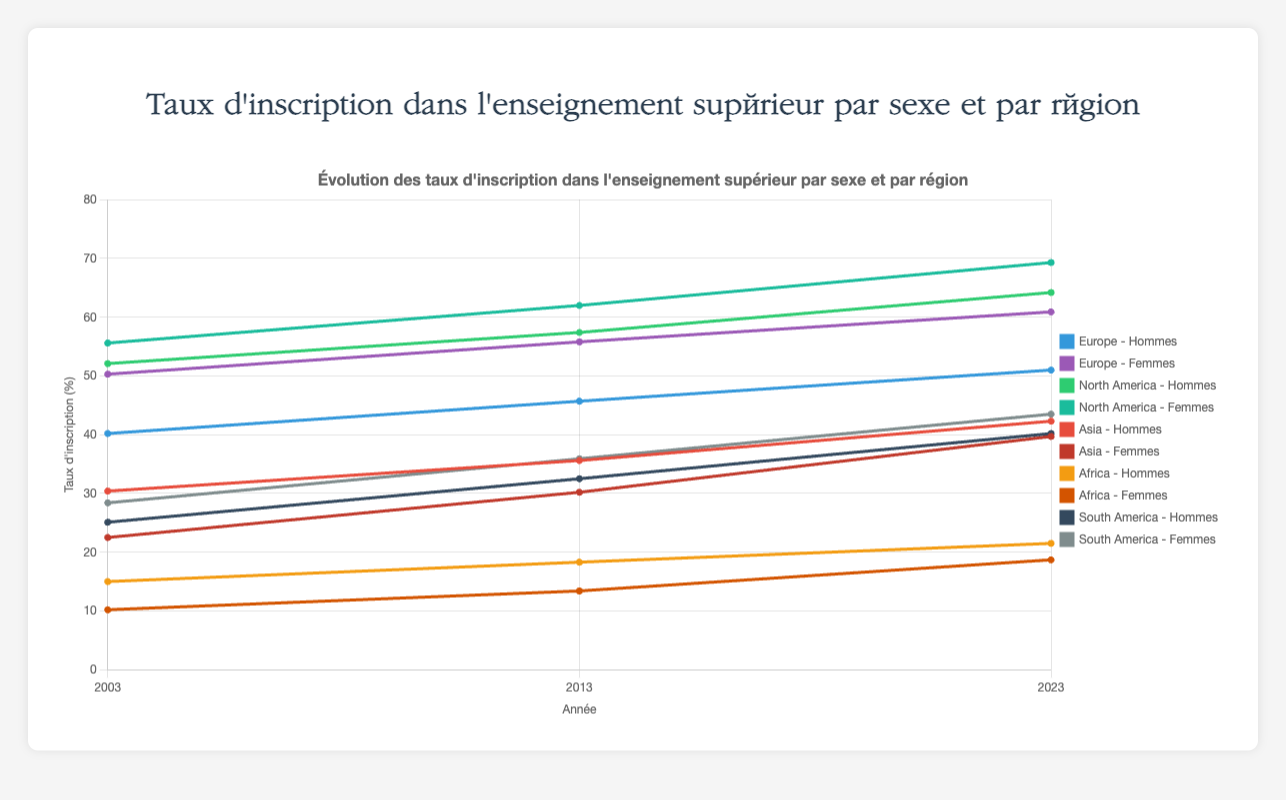Quelle région avait la différence la plus élevée entre les taux d'inscription des hommes et des femmes en 2003 ? Pour chaque région en 2003, soustrayez le taux d'inscription des femmes de celui des hommes : Europe (50.3 - 40.2 = 10.1), Amérique du Nord (55.6 - 52.1 = 3.5), Asie (30.4 - 22.5 = 7.9), Afrique (15.0 - 10.2 = 4.8), Amérique du Sud (28.4 - 25.1 = 3.3). La plus grande différence est en Europe avec 10.1.
Answer: Europe Quel était le taux d'inscription moyen des femmes dans toutes les régions en 2023 ? Additionnez les taux d'inscription des femmes dans chaque région en 2023 et divisez par le nombre de régions : (60.9 + 69.3 + 39.7 + 18.7 + 43.5) / 5 = 46.42.
Answer: 46.42 En quelle année l'écart entre les taux d'inscription des hommes et des femmes en Amérique du Nord était-il le plus grand ? Soustrayez le taux d'inscription des hommes de celui des femmes en Amérique du Nord pour chaque année : 2003 (55.6 - 52.1 = 3.5), 2013 (62.0 - 57.4 = 4.6), 2023 (69.3 - 64.2 = 5.1). L'écart le plus grand est en 2023 avec 5.1.
Answer: 2023 Quelle région a montré l'augmentation la plus faible dans les taux d'inscription des hommes de 2003 à 2023 ? Pour chaque région, calculez l'augmentation entre 2023 et 2003 pour les hommes : Europe (51.0 - 40.2 = 10.8), Amérique du Nord (64.2 - 52.1 = 12.1), Asie (42.3 - 30.4 = 11.9), Afrique (21.5 - 15.0 = 6.5), Amérique du Sud (40.2 - 25.1 = 15.1). L'augmentation la plus faible est en Afrique avec 6.5.
Answer: Afrique Quelle région a les taux d'inscription les plus élevés pour les deux sexes combinés en 2023 ? Additionnez les taux d'inscription des hommes et des femmes pour chaque région en 2023 : Europe (51.0 + 60.9 = 111.9), Amérique du Nord (64.2 + 69.3 = 133.5), Asie (42.3 + 39.7 = 82.0), Afrique (21.5 + 18.7 = 40.2), Amérique du Sud (40.2 + 43.5 = 83.7). La région avec le total le plus élevé est l'Amérique du Nord avec 133.5.
Answer: Amérique du Nord Quel est le taux global de croissance des taux d'inscription masculins en Asie de 2003 à 2023 ? Calculez le taux de croissance en utilisant la formule : ((taux final - taux initial) / taux initial) * 100 pour les hommes en Asie entre 2003 et 2023 : ((42.3 - 30.4) / 30.4) * 100 = 39.14%.
Answer: 39.14% Quelle région affichait le plus bas taux d'inscription pour les femmes en 2003 ? Comparer les taux d'inscription des femmes en 2003 pour chaque région : Europe (50.3), Amérique du Nord (55.6), Asie (22.5), Afrique (10.2), Amérique du Sud (28.4). Le taux le plus bas est en Afrique avec 10.2.
Answer: Afrique Quelle région a vu la plus grande augmentation du taux d'inscription des femmes entre 2003 et 2023 ? Pour chaque région, calculez l'augmentation du taux d'inscription des femmes entre 2003 et 2023 : Europe (60.9 - 50.3 = 10.6), Amérique du Nord (69.3 - 55.6 = 13.7), Asie (39.7 - 22.5 = 17.2), Afrique (18.7 - 10.2 = 8.5), Amérique du Sud (43.5 - 28.4 = 15.1). La plus grande augmentation est en Asie avec 17.2.
Answer: Asie 